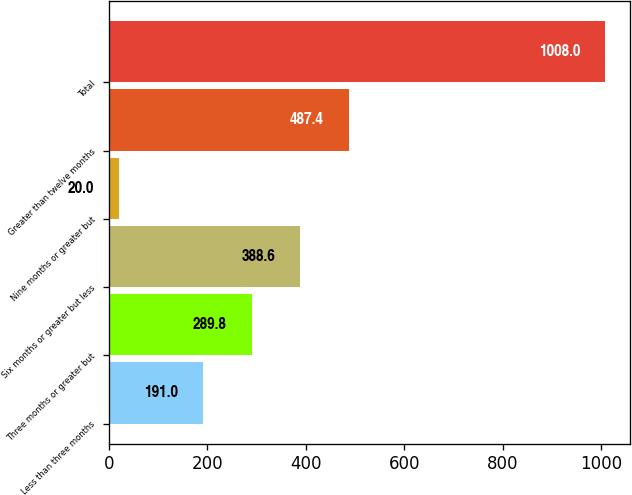<chart> <loc_0><loc_0><loc_500><loc_500><bar_chart><fcel>Less than three months<fcel>Three months or greater but<fcel>Six months or greater but less<fcel>Nine months or greater but<fcel>Greater than twelve months<fcel>Total<nl><fcel>191<fcel>289.8<fcel>388.6<fcel>20<fcel>487.4<fcel>1008<nl></chart> 